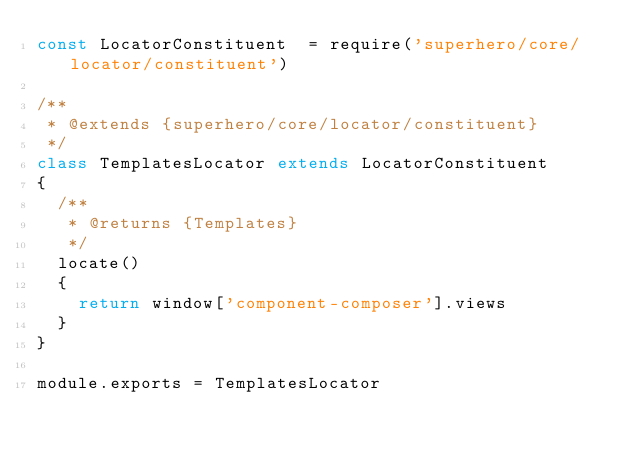Convert code to text. <code><loc_0><loc_0><loc_500><loc_500><_JavaScript_>const LocatorConstituent  = require('superhero/core/locator/constituent')

/**
 * @extends {superhero/core/locator/constituent}
 */
class TemplatesLocator extends LocatorConstituent
{
  /**
   * @returns {Templates}
   */
  locate()
  {
    return window['component-composer'].views
  }
}

module.exports = TemplatesLocator
</code> 